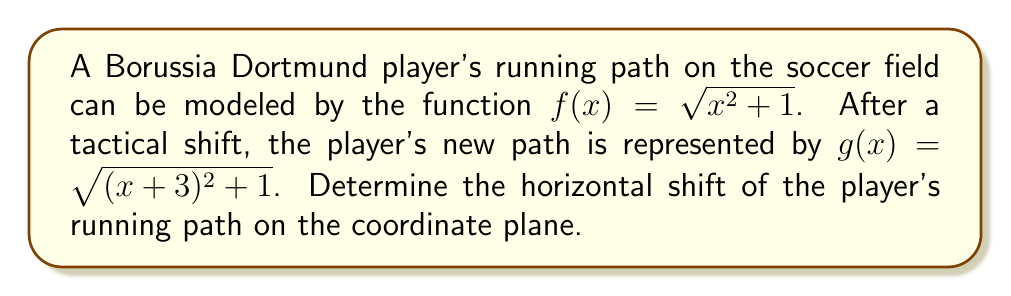Can you solve this math problem? To find the horizontal shift, we need to compare the original function $f(x)$ with the new function $g(x)$:

1) The original function: $f(x) = \sqrt{x^2 + 1}$
2) The new function: $g(x) = \sqrt{(x+3)^2 + 1}$

3) In general, for a function $f(x)$, a horizontal shift of $h$ units to the left is represented by $f(x+h)$.

4) Comparing $g(x)$ to the general form:
   $g(x) = \sqrt{(x+3)^2 + 1} = f(x+3)$

5) This means that each point on the graph of $f(x)$ has been shifted 3 units to the left.

6) In the context of a coordinate plane, a shift to the left is considered a negative shift.

Therefore, the horizontal shift is 3 units to the left, or -3 units.
Answer: -3 units 